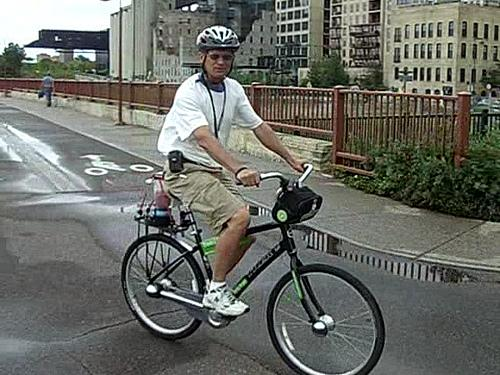What is above the bicycle? Please explain your reasoning. man. A man is sitting on the bicycle. he is wearing a helmet. 